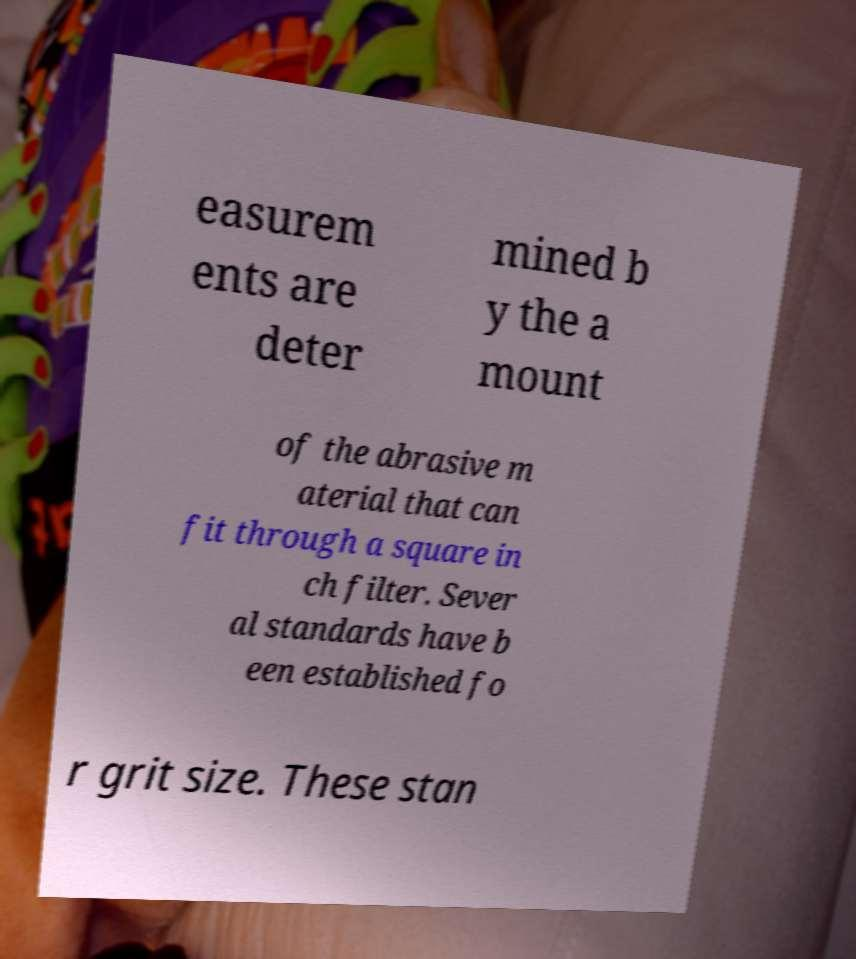Could you extract and type out the text from this image? easurem ents are deter mined b y the a mount of the abrasive m aterial that can fit through a square in ch filter. Sever al standards have b een established fo r grit size. These stan 